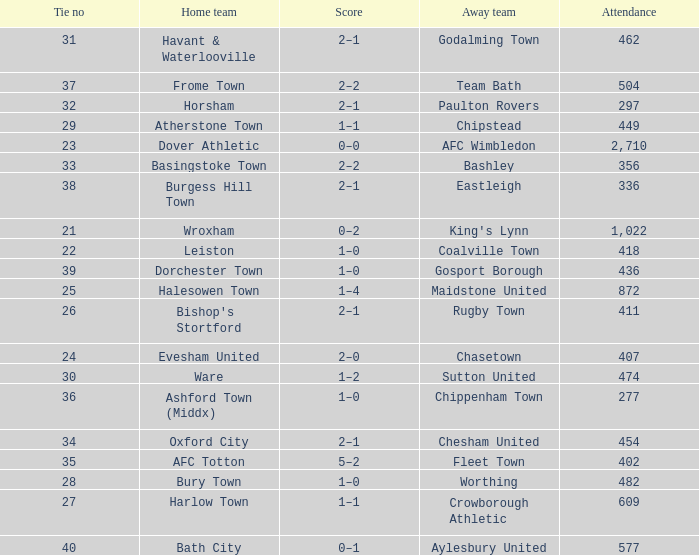What is the away team of the match with a 356 attendance? Bashley. 